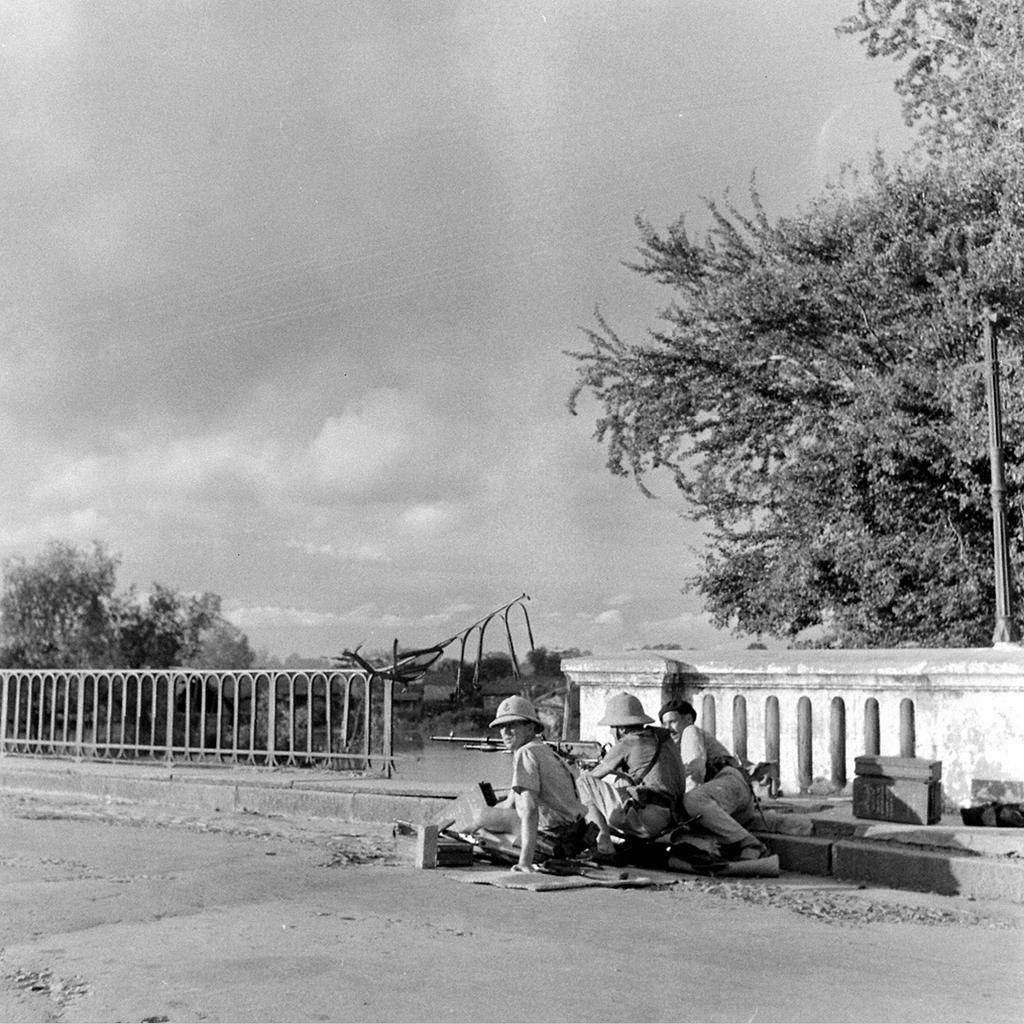How many people are sitting in the middle of the image? There are three persons sitting in the middle of the image. What can be seen on the right side of the image? There is a tree on the right side of the image. What is the color scheme of the image? The image is black and white. What type of plough is being used by the persons in the image? There is no plough present in the image; it features three persons sitting in the middle and a tree on the right side. 